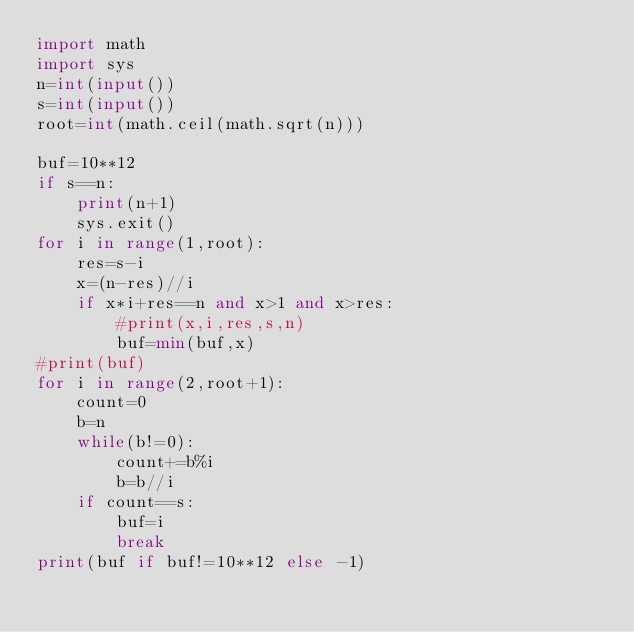<code> <loc_0><loc_0><loc_500><loc_500><_Python_>import math
import sys
n=int(input())
s=int(input())
root=int(math.ceil(math.sqrt(n)))

buf=10**12
if s==n:
    print(n+1)
    sys.exit()
for i in range(1,root):
    res=s-i
    x=(n-res)//i
    if x*i+res==n and x>1 and x>res:
        #print(x,i,res,s,n)
        buf=min(buf,x)
#print(buf)
for i in range(2,root+1):
    count=0
    b=n
    while(b!=0):
        count+=b%i
        b=b//i
    if count==s:
        buf=i
        break
print(buf if buf!=10**12 else -1)</code> 